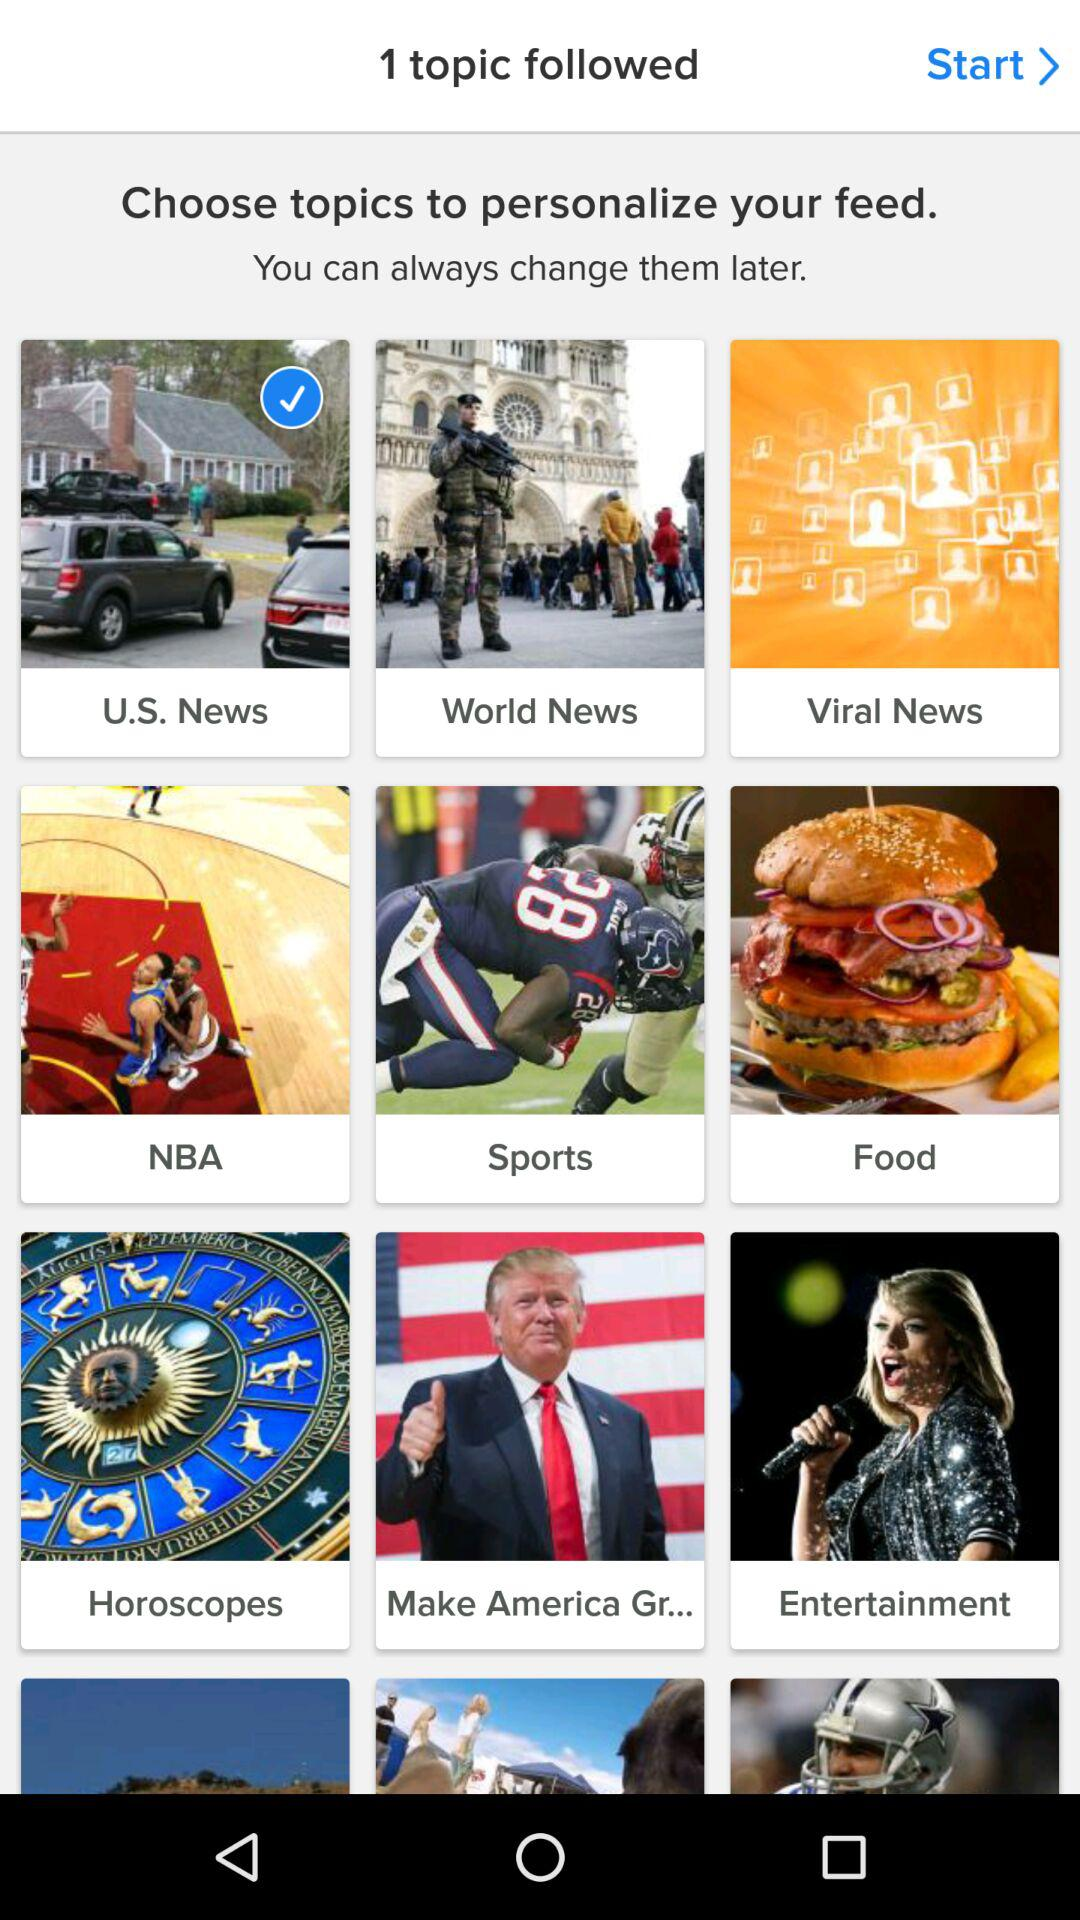How many topics are there in the first row?
Answer the question using a single word or phrase. 3 